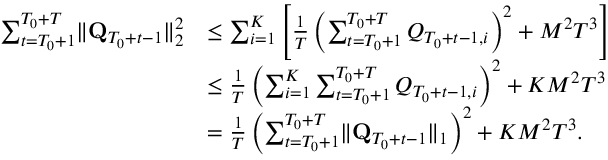Convert formula to latex. <formula><loc_0><loc_0><loc_500><loc_500>\begin{array} { r l } { \sum _ { t = T _ { 0 } + 1 } ^ { T _ { 0 } + T } \| \mathbf Q _ { T _ { 0 } + t - 1 } \| _ { 2 } ^ { 2 } } & { \leq \sum _ { i = 1 } ^ { K } \left [ \frac { 1 } { T } \left ( \sum _ { t = T _ { 0 } + 1 } ^ { T _ { 0 } + T } Q _ { T _ { 0 } + t - 1 , i } \right ) ^ { 2 } + M ^ { 2 } T ^ { 3 } \right ] } \\ & { \leq \frac { 1 } { T } \left ( \sum _ { i = 1 } ^ { K } \sum _ { t = T _ { 0 } + 1 } ^ { T _ { 0 } + T } Q _ { T _ { 0 } + t - 1 , i } \right ) ^ { 2 } + K M ^ { 2 } T ^ { 3 } } \\ & { = \frac { 1 } { T } \left ( \sum _ { t = T _ { 0 } + 1 } ^ { T _ { 0 } + T } \| \mathbf Q _ { T _ { 0 } + t - 1 } \| _ { 1 } \right ) ^ { 2 } + K M ^ { 2 } T ^ { 3 } . } \end{array}</formula> 